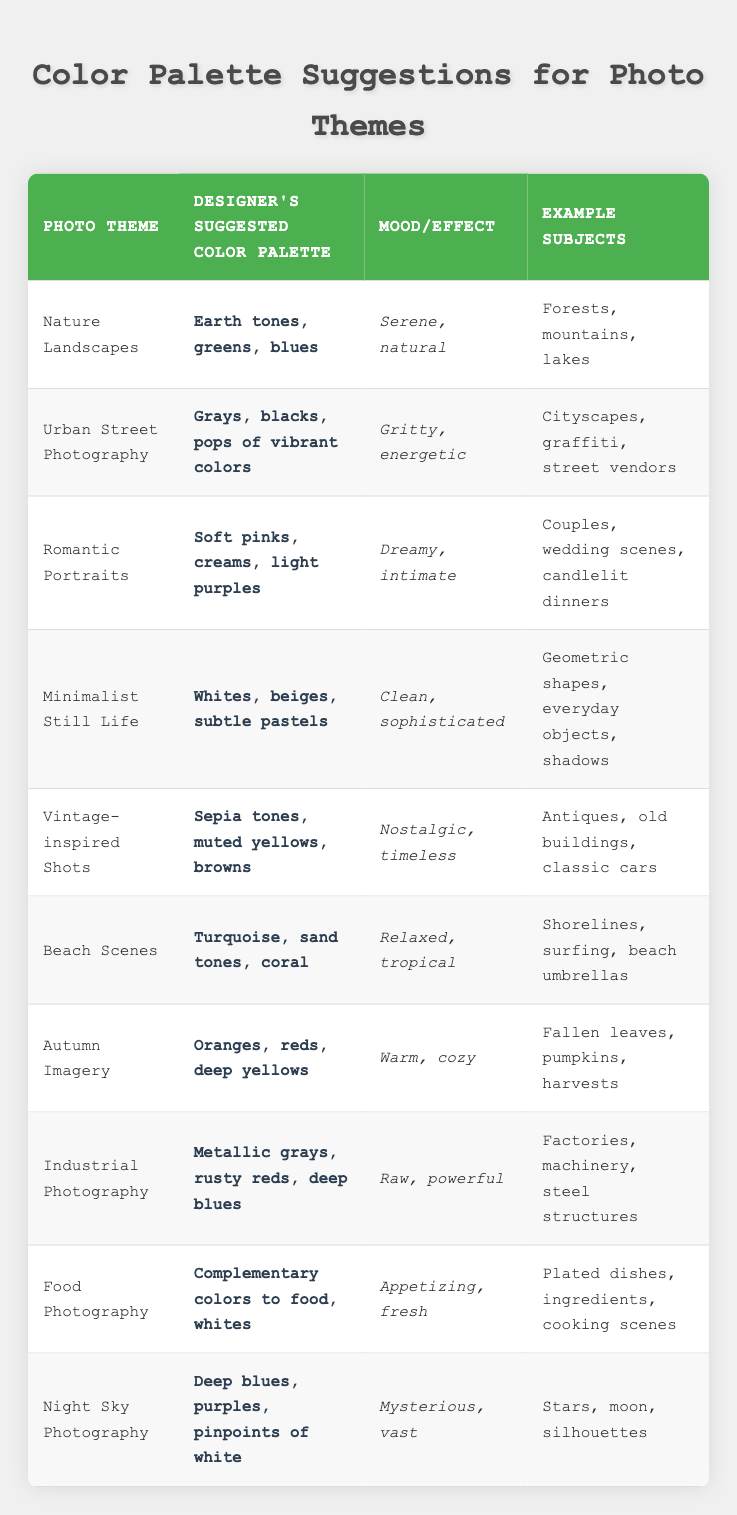What color palette is suggested for Nature Landscapes? The table directly lists "Earth tones, greens, blues" as the suggested color palette for the Nature Landscapes theme.
Answer: Earth tones, greens, blues Which photo theme has a nostalgic and timeless mood? The theme with a "Nostalgic, timeless" mood is found by looking through the moods in the table and identifying "Vintage-inspired Shots," which is associated with sepia tones, muted yellows, and browns.
Answer: Vintage-inspired Shots Are soft pinks and creams suggested for Food Photography? The table indicates that "Soft pinks, creams, light purples" are suggested for Romantic Portraits, not Food Photography. Therefore, this statement is false.
Answer: No What is the mood associated with Beach Scenes? According to the table, the mood listed for Beach Scenes is "Relaxed, tropical," which is clearly stated alongside the recommended color palette of turquoise, sand tones, and coral.
Answer: Relaxed, tropical How many themes suggest using warm colors? The themes associated with warm colors are "Autumn Imagery," which suggests oranges, reds, and deep yellows; and "Vintage-inspired Shots," which has sepia tones and muted yellows. Counting these themes shows that there are two.
Answer: Two Which theme uses deep blue colors? The themes using deep blue colors include "Night Sky Photography" with deep blues and purples, and "Industrial Photography," which includes deep blues in a palette of metallic grays, rusty reds, and deep blues. Therefore, both themes apply.
Answer: Night Sky Photography, Industrial Photography Can you find a color palette that includes whites? Yes, the table shows that both "Food Photography" and "Minimalist Still Life" suggest using whites in their color palettes. Thus, the statement is true.
Answer: Yes Which photo theme has the most vibrant suggested colors? The "Urban Street Photography" theme is characterized by a palette of grays, blacks, and pops of vibrant colors. This indicates a more energetic color use compared to other themes.
Answer: Urban Street Photography What mood is linked to Industrial Photography? The table lists "Raw, powerful" as the mood linked to Industrial Photography. This is summarized from the color palette of metallic grays, rusty reds, and deep blues.
Answer: Raw, powerful 